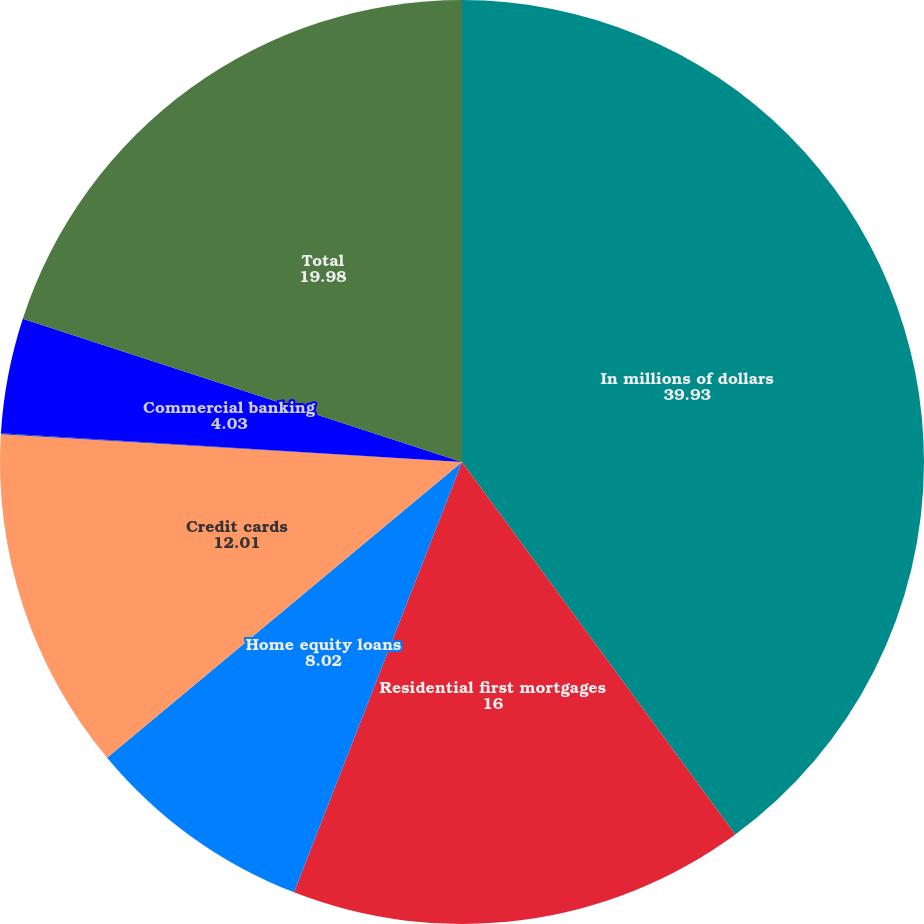<chart> <loc_0><loc_0><loc_500><loc_500><pie_chart><fcel>In millions of dollars<fcel>Residential first mortgages<fcel>Home equity loans<fcel>Credit cards<fcel>Installment and other<fcel>Commercial banking<fcel>Total<nl><fcel>39.93%<fcel>16.0%<fcel>8.02%<fcel>12.01%<fcel>0.04%<fcel>4.03%<fcel>19.98%<nl></chart> 